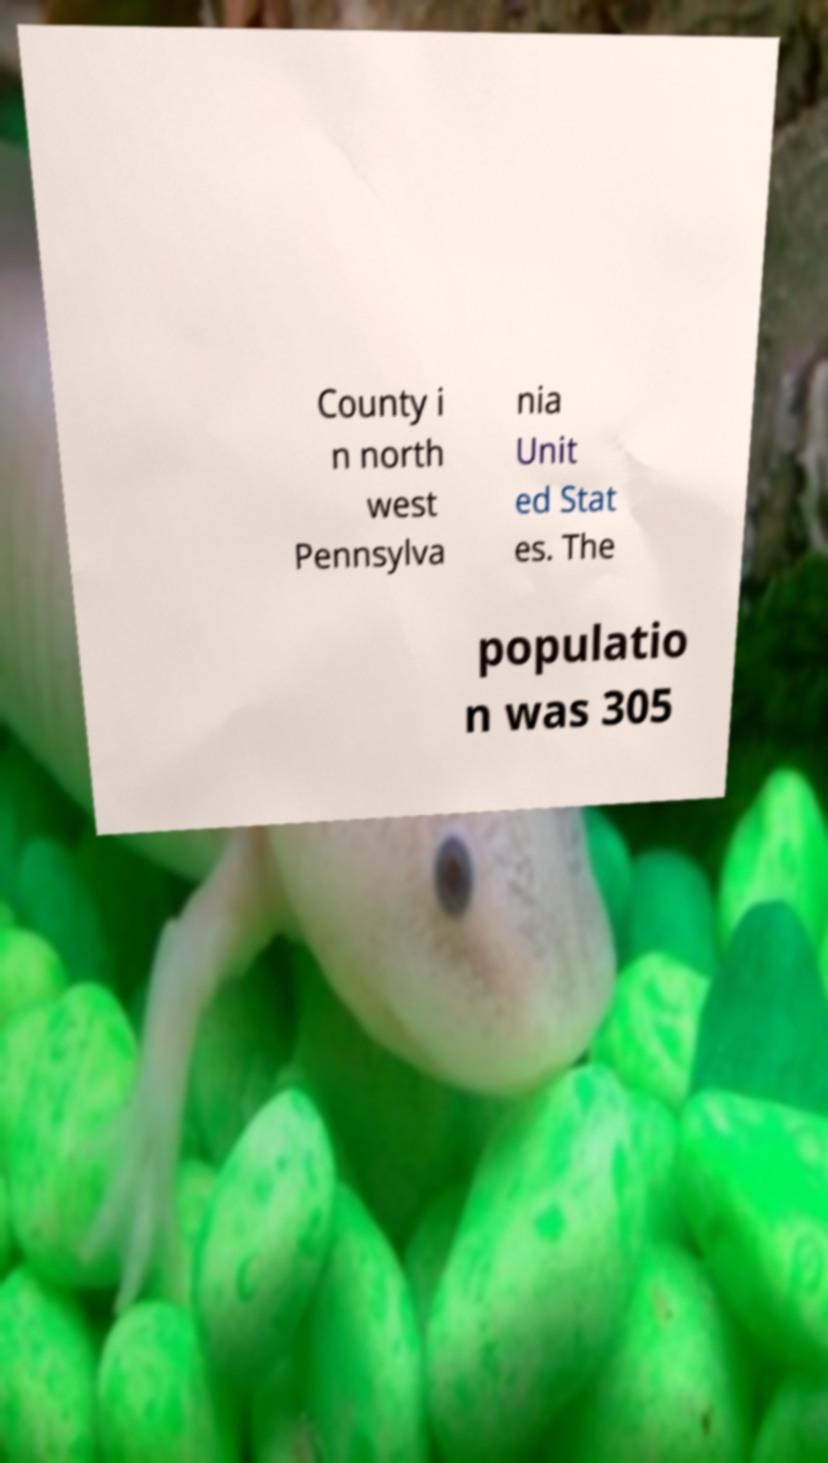Can you accurately transcribe the text from the provided image for me? County i n north west Pennsylva nia Unit ed Stat es. The populatio n was 305 